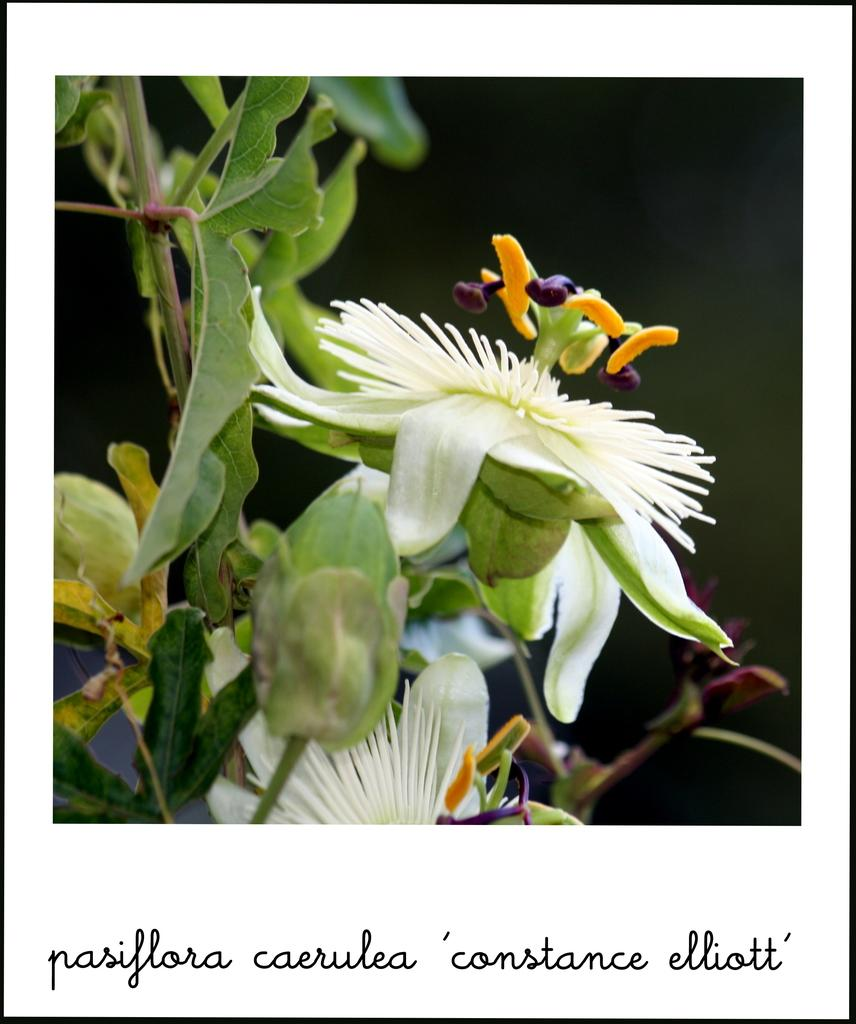What is the main subject of the poster in the image? The poster contains images of flowers and plants. How is the area behind the plants depicted in the poster? The area behind the plants in the poster is blurred. Is there any text on the poster? Yes, there is text at the bottom of the poster. What type of feeling is expressed by the bridge in the image? There is no bridge present in the image, so it is not possible to determine what feeling it might express. 